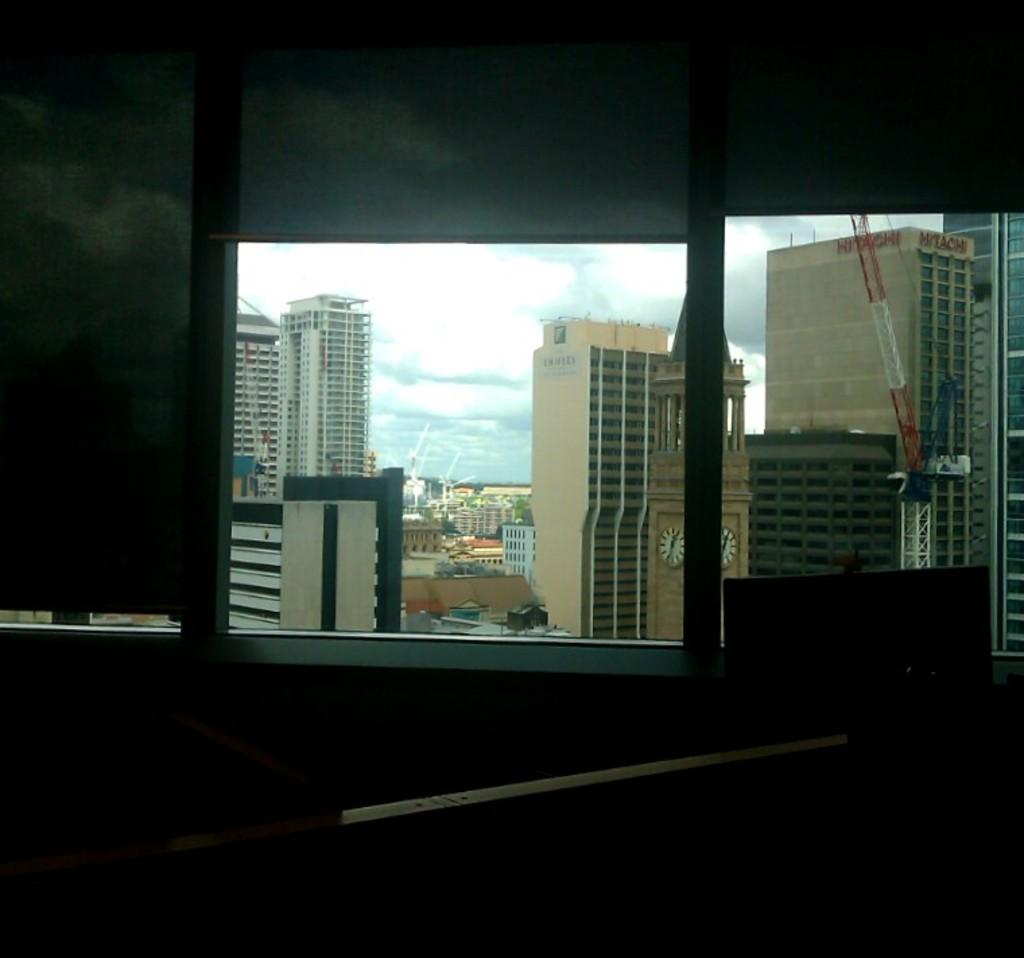What can be seen in the image that allows light to enter a room? There are windows in the image. What type of structures are visible in the background of the image? There are buildings in the background of the image. What colors are the buildings in the image? The buildings are in white, cream, and brown colors. What type of vegetation is present in the image? There are trees in the image. What color are the trees in the image? The trees are green. What is visible in the sky in the image? The sky is blue and white in color. Can you see any dinosaurs grazing in the field in the image? There is no field or dinosaurs present in the image. 